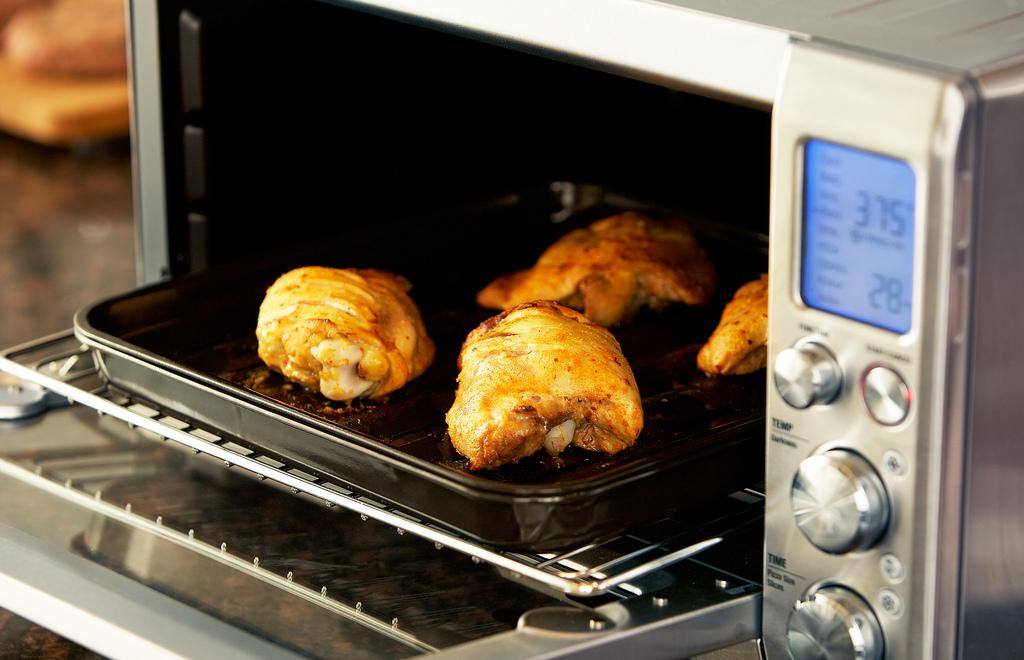Provide a one-sentence caption for the provided image. toaster oven is set at 375 and is baking chicken. 